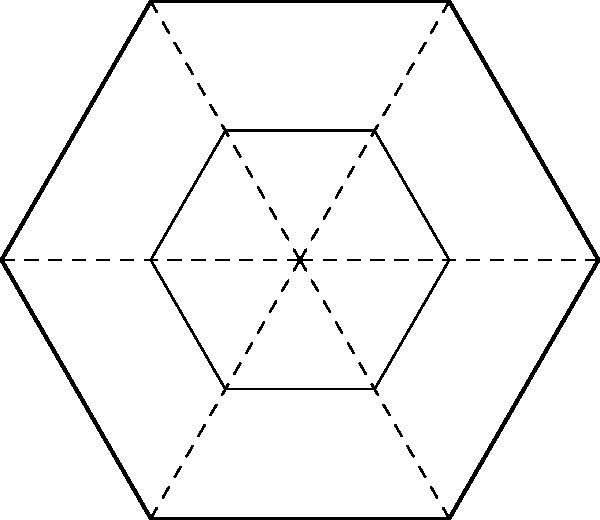In your parent's homeland, a traditional hexagonal pattern is commonly used in decorative arts. The pattern consists of a large hexagon with smaller hexagons inside, rotated at regular intervals. If the large hexagon has a side length of 10 cm, and each smaller hexagon has a side length exactly half of the large one, how many lines of symmetry does this entire pattern have? To determine the number of lines of symmetry in this pattern, we need to consider the symmetry of both the large hexagon and the arrangement of smaller hexagons within it:

1. A regular hexagon has 12 lines of symmetry:
   - 6 lines connecting opposite vertices
   - 6 lines connecting the midpoints of opposite sides

2. In this pattern, the smaller hexagons are placed in a way that preserves all these lines of symmetry:
   - They are scaled versions of the large hexagon (half the side length)
   - They are rotated at regular 60° intervals

3. The placement of smaller hexagons doesn't introduce any new lines of symmetry, nor does it eliminate any existing ones.

4. Therefore, the entire pattern maintains all 12 lines of symmetry of the original hexagon.

The number of lines of symmetry is independent of the actual size of the hexagons, so the given measurements (10 cm for the large hexagon, 5 cm for the smaller ones) don't affect the symmetry count.
Answer: 12 